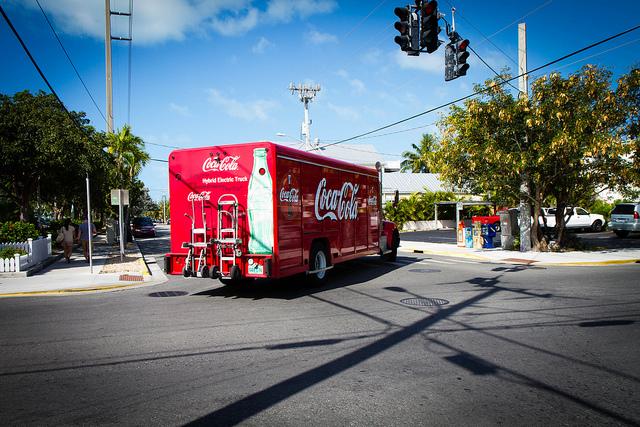What is in the colorful boxes on the far corner of the intersection?
Short answer required. Newspapers. What color is the truck?
Give a very brief answer. Red. What brand of soda is on the truck?
Concise answer only. Coca cola. 